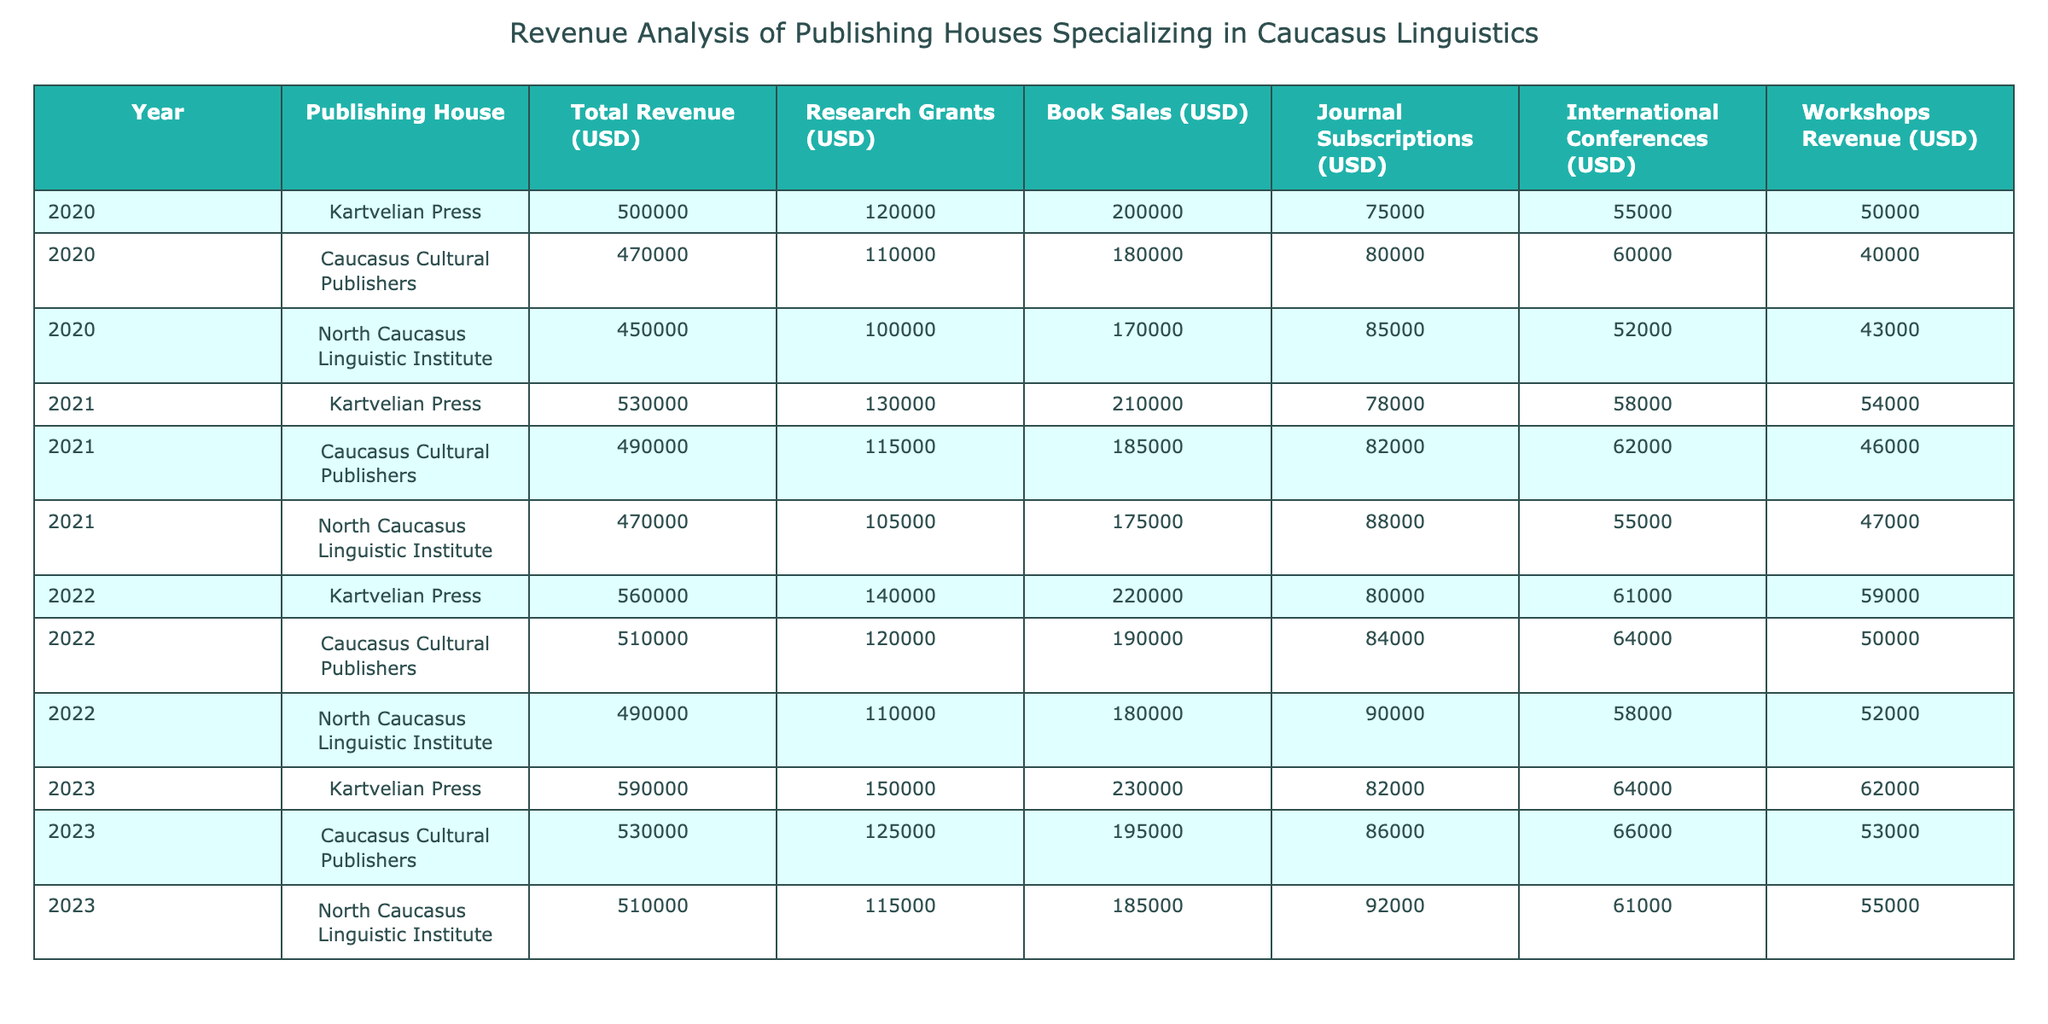What was the total revenue for Kartvelian Press in 2021? The table shows that the total revenue for Kartvelian Press in 2021 is listed as 530000 USD.
Answer: 530000 USD What is the year with the highest book sales among the publishing houses? By comparing the book sales across all years for each publishing house, the highest figure is 230000 USD in 2023 for Kartvelian Press.
Answer: 2023 Did the North Caucasus Linguistic Institute receive more research grants in 2022 compared to 2021? In 2022, the North Caucasus Linguistic Institute received research grants of 110000 USD, and in 2021, it received 105000 USD. Since 110000 USD is greater than 105000 USD, the answer is yes.
Answer: Yes What is the average revenue from journal subscriptions for Caucasus Cultural Publishers over the four years? The journal subscription revenues are 80000 USD (2020), 82000 USD (2021), 84000 USD (2022), and 86000 USD (2023). Adding these gives a total of 328000 USD, and dividing by 4 yields an average of 82000 USD.
Answer: 82000 USD Which publishing house had the lowest total revenue in 2020, and what was that amount? By examining the total revenue figures for 2020: Kartvelian Press (500000 USD), Caucasus Cultural Publishers (470000 USD), and North Caucasus Linguistic Institute (450000 USD), North Caucasus Linguistic Institute had the lowest amount at 450000 USD.
Answer: North Caucasus Linguistic Institute, 450000 USD What was the total revenue from workshops for Kartvelian Press over the four years? The workshop revenues for Kartvelian Press were 50000 USD (2020), 54000 USD (2021), 59000 USD (2022), and 62000 USD (2023). Adding these amounts gives a total of 50000 + 54000 + 59000 + 62000 = 225000 USD.
Answer: 225000 USD Did Caucasus Cultural Publishers increase their total revenue every year from 2020 to 2023? Checking the total revenue for Caucasus Cultural Publishers: 470000 USD (2020), 490000 USD (2021), 510000 USD (2022), and 530000 USD (2023) shows that revenue consistently increased each year. Therefore, the answer is yes.
Answer: Yes What is the difference in total revenue for North Caucasus Linguistic Institute from 2020 to 2023? The total revenue for North Caucasus Linguistic Institute in 2020 was 450000 USD and in 2023 it was 510000 USD. The difference is calculated as 510000 - 450000 = 60000 USD.
Answer: 60000 USD 